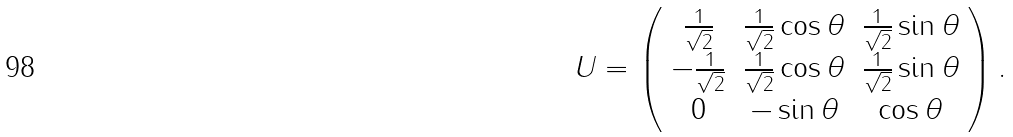<formula> <loc_0><loc_0><loc_500><loc_500>U = \left ( \begin{array} { c c c } { { { \frac { 1 } { \sqrt { 2 } } } } } & { { { \frac { 1 } { \sqrt { 2 } } } \cos \theta } } & { { { \frac { 1 } { \sqrt { 2 } } } \sin \theta } } \\ { { - { \frac { 1 } { \sqrt { 2 } } } } } & { { { \frac { 1 } { \sqrt { 2 } } } \cos \theta } } & { { { \frac { 1 } { \sqrt { 2 } } } \sin \theta } } \\ { 0 } & { - \sin \theta } & { \cos \theta } \end{array} \right ) .</formula> 